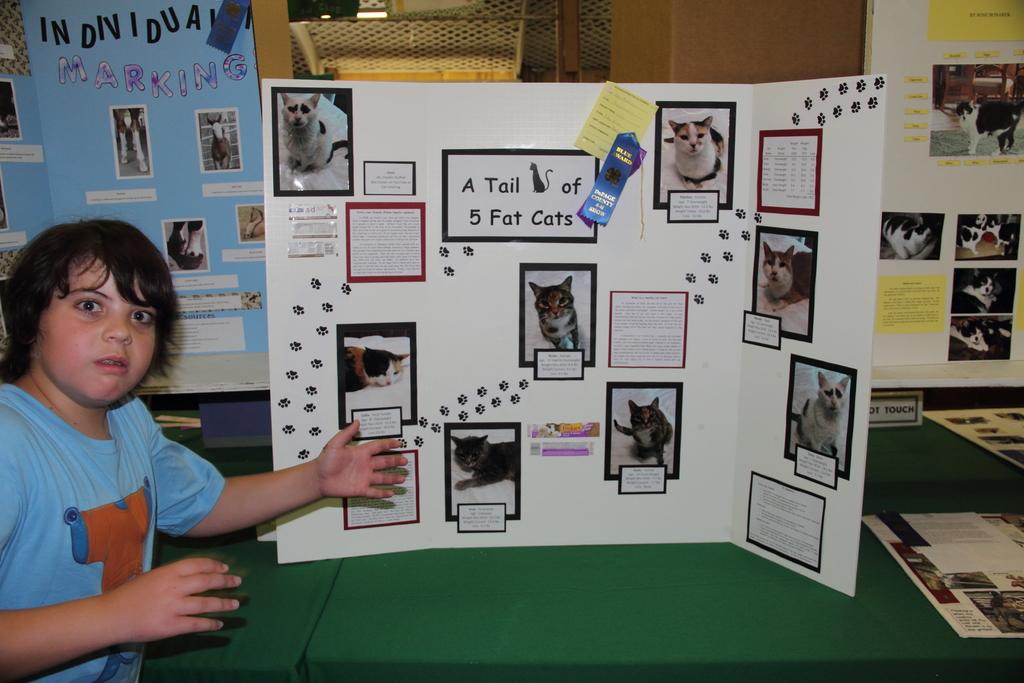What does it say on the white and black square on the back?
Offer a very short reply. A tail of 5 fat cats. This is notice board?
Provide a short and direct response. No. 